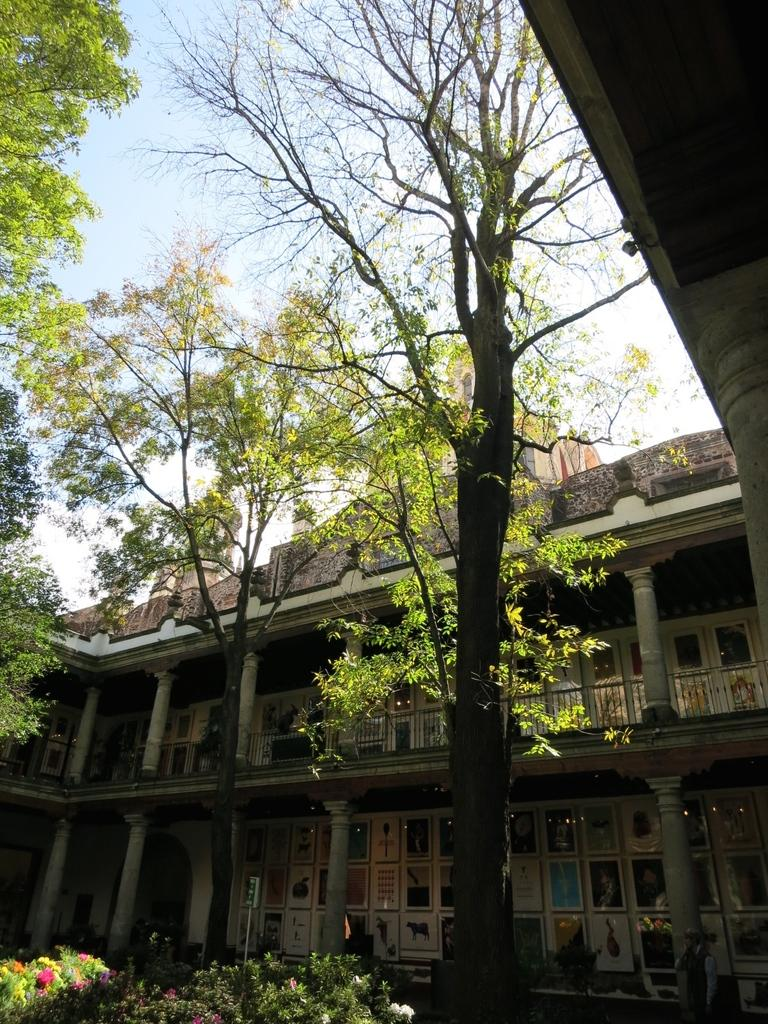What type of vegetation can be seen in the image? There are trees and plants in the image. What type of structures are present in the image? There are buildings and pillars in the image. What decorative elements can be seen in the image? There are photo frames in the image. What can be seen in the sky in the image? The sky is visible in the image. How many crates are stacked next to the trees in the image? There are no crates present in the image. What is the value of the dime on top of the photo frame in the image? There is no dime present in the image. 